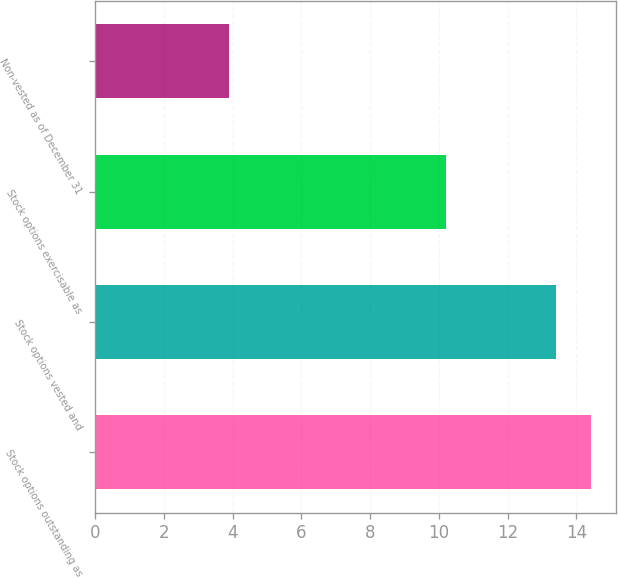<chart> <loc_0><loc_0><loc_500><loc_500><bar_chart><fcel>Stock options outstanding as<fcel>Stock options vested and<fcel>Stock options exercisable as<fcel>Non-vested as of December 31<nl><fcel>14.42<fcel>13.4<fcel>10.2<fcel>3.9<nl></chart> 